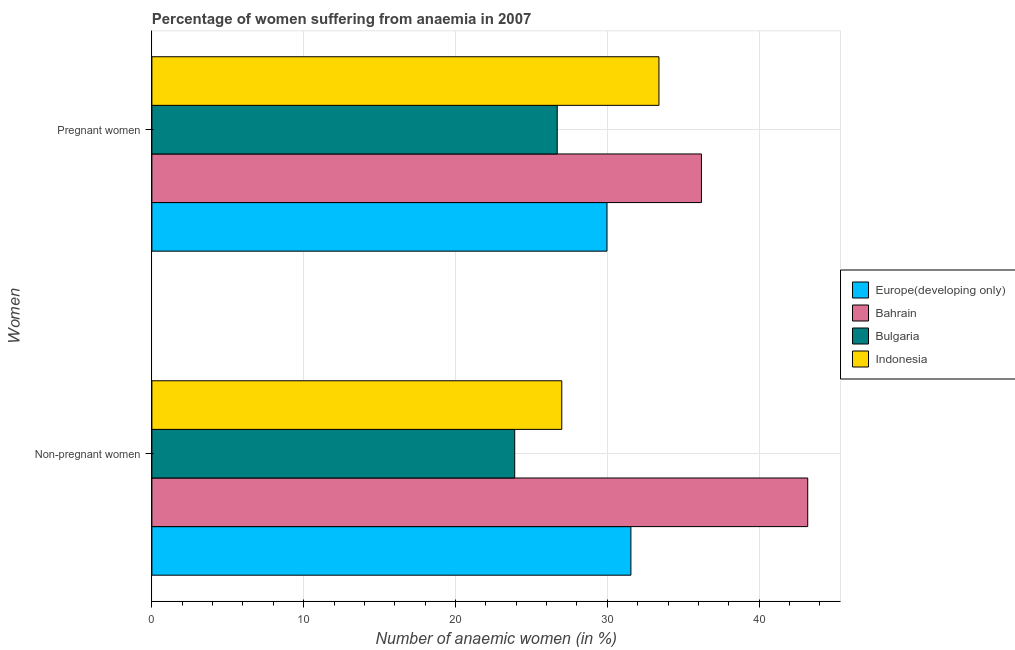How many different coloured bars are there?
Give a very brief answer. 4. Are the number of bars on each tick of the Y-axis equal?
Your response must be concise. Yes. How many bars are there on the 2nd tick from the top?
Give a very brief answer. 4. What is the label of the 2nd group of bars from the top?
Give a very brief answer. Non-pregnant women. What is the percentage of pregnant anaemic women in Europe(developing only)?
Your answer should be compact. 29.98. Across all countries, what is the maximum percentage of non-pregnant anaemic women?
Provide a short and direct response. 43.2. Across all countries, what is the minimum percentage of pregnant anaemic women?
Your answer should be very brief. 26.7. In which country was the percentage of non-pregnant anaemic women maximum?
Keep it short and to the point. Bahrain. In which country was the percentage of pregnant anaemic women minimum?
Provide a short and direct response. Bulgaria. What is the total percentage of pregnant anaemic women in the graph?
Offer a very short reply. 126.28. What is the difference between the percentage of pregnant anaemic women in Bulgaria and that in Indonesia?
Give a very brief answer. -6.7. What is the difference between the percentage of non-pregnant anaemic women in Bahrain and the percentage of pregnant anaemic women in Europe(developing only)?
Keep it short and to the point. 13.22. What is the average percentage of non-pregnant anaemic women per country?
Ensure brevity in your answer.  31.41. What is the difference between the percentage of non-pregnant anaemic women and percentage of pregnant anaemic women in Bulgaria?
Make the answer very short. -2.8. What is the ratio of the percentage of pregnant anaemic women in Indonesia to that in Bahrain?
Give a very brief answer. 0.92. Is the percentage of pregnant anaemic women in Indonesia less than that in Bulgaria?
Keep it short and to the point. No. In how many countries, is the percentage of non-pregnant anaemic women greater than the average percentage of non-pregnant anaemic women taken over all countries?
Provide a succinct answer. 2. What does the 4th bar from the top in Pregnant women represents?
Keep it short and to the point. Europe(developing only). How many countries are there in the graph?
Your response must be concise. 4. What is the difference between two consecutive major ticks on the X-axis?
Give a very brief answer. 10. Does the graph contain grids?
Your response must be concise. Yes. How many legend labels are there?
Your answer should be very brief. 4. How are the legend labels stacked?
Offer a very short reply. Vertical. What is the title of the graph?
Provide a short and direct response. Percentage of women suffering from anaemia in 2007. Does "East Asia (developing only)" appear as one of the legend labels in the graph?
Ensure brevity in your answer.  No. What is the label or title of the X-axis?
Your answer should be very brief. Number of anaemic women (in %). What is the label or title of the Y-axis?
Your answer should be compact. Women. What is the Number of anaemic women (in %) of Europe(developing only) in Non-pregnant women?
Offer a terse response. 31.55. What is the Number of anaemic women (in %) of Bahrain in Non-pregnant women?
Keep it short and to the point. 43.2. What is the Number of anaemic women (in %) of Bulgaria in Non-pregnant women?
Offer a terse response. 23.9. What is the Number of anaemic women (in %) in Europe(developing only) in Pregnant women?
Offer a very short reply. 29.98. What is the Number of anaemic women (in %) in Bahrain in Pregnant women?
Your answer should be compact. 36.2. What is the Number of anaemic women (in %) of Bulgaria in Pregnant women?
Ensure brevity in your answer.  26.7. What is the Number of anaemic women (in %) in Indonesia in Pregnant women?
Provide a succinct answer. 33.4. Across all Women, what is the maximum Number of anaemic women (in %) in Europe(developing only)?
Offer a very short reply. 31.55. Across all Women, what is the maximum Number of anaemic women (in %) in Bahrain?
Your answer should be very brief. 43.2. Across all Women, what is the maximum Number of anaemic women (in %) of Bulgaria?
Your answer should be very brief. 26.7. Across all Women, what is the maximum Number of anaemic women (in %) in Indonesia?
Provide a short and direct response. 33.4. Across all Women, what is the minimum Number of anaemic women (in %) of Europe(developing only)?
Your answer should be very brief. 29.98. Across all Women, what is the minimum Number of anaemic women (in %) in Bahrain?
Keep it short and to the point. 36.2. Across all Women, what is the minimum Number of anaemic women (in %) of Bulgaria?
Your answer should be very brief. 23.9. What is the total Number of anaemic women (in %) in Europe(developing only) in the graph?
Your answer should be compact. 61.53. What is the total Number of anaemic women (in %) in Bahrain in the graph?
Offer a very short reply. 79.4. What is the total Number of anaemic women (in %) in Bulgaria in the graph?
Offer a terse response. 50.6. What is the total Number of anaemic women (in %) of Indonesia in the graph?
Your answer should be very brief. 60.4. What is the difference between the Number of anaemic women (in %) of Europe(developing only) in Non-pregnant women and that in Pregnant women?
Make the answer very short. 1.58. What is the difference between the Number of anaemic women (in %) of Bulgaria in Non-pregnant women and that in Pregnant women?
Your answer should be very brief. -2.8. What is the difference between the Number of anaemic women (in %) in Indonesia in Non-pregnant women and that in Pregnant women?
Offer a terse response. -6.4. What is the difference between the Number of anaemic women (in %) in Europe(developing only) in Non-pregnant women and the Number of anaemic women (in %) in Bahrain in Pregnant women?
Ensure brevity in your answer.  -4.65. What is the difference between the Number of anaemic women (in %) of Europe(developing only) in Non-pregnant women and the Number of anaemic women (in %) of Bulgaria in Pregnant women?
Provide a short and direct response. 4.85. What is the difference between the Number of anaemic women (in %) of Europe(developing only) in Non-pregnant women and the Number of anaemic women (in %) of Indonesia in Pregnant women?
Provide a short and direct response. -1.85. What is the difference between the Number of anaemic women (in %) of Bahrain in Non-pregnant women and the Number of anaemic women (in %) of Bulgaria in Pregnant women?
Provide a succinct answer. 16.5. What is the difference between the Number of anaemic women (in %) of Bulgaria in Non-pregnant women and the Number of anaemic women (in %) of Indonesia in Pregnant women?
Provide a succinct answer. -9.5. What is the average Number of anaemic women (in %) in Europe(developing only) per Women?
Your answer should be very brief. 30.76. What is the average Number of anaemic women (in %) of Bahrain per Women?
Keep it short and to the point. 39.7. What is the average Number of anaemic women (in %) in Bulgaria per Women?
Provide a short and direct response. 25.3. What is the average Number of anaemic women (in %) of Indonesia per Women?
Keep it short and to the point. 30.2. What is the difference between the Number of anaemic women (in %) of Europe(developing only) and Number of anaemic women (in %) of Bahrain in Non-pregnant women?
Your answer should be compact. -11.65. What is the difference between the Number of anaemic women (in %) of Europe(developing only) and Number of anaemic women (in %) of Bulgaria in Non-pregnant women?
Give a very brief answer. 7.65. What is the difference between the Number of anaemic women (in %) of Europe(developing only) and Number of anaemic women (in %) of Indonesia in Non-pregnant women?
Your answer should be compact. 4.55. What is the difference between the Number of anaemic women (in %) in Bahrain and Number of anaemic women (in %) in Bulgaria in Non-pregnant women?
Provide a short and direct response. 19.3. What is the difference between the Number of anaemic women (in %) of Bahrain and Number of anaemic women (in %) of Indonesia in Non-pregnant women?
Ensure brevity in your answer.  16.2. What is the difference between the Number of anaemic women (in %) of Bulgaria and Number of anaemic women (in %) of Indonesia in Non-pregnant women?
Your answer should be very brief. -3.1. What is the difference between the Number of anaemic women (in %) of Europe(developing only) and Number of anaemic women (in %) of Bahrain in Pregnant women?
Ensure brevity in your answer.  -6.22. What is the difference between the Number of anaemic women (in %) in Europe(developing only) and Number of anaemic women (in %) in Bulgaria in Pregnant women?
Your answer should be compact. 3.28. What is the difference between the Number of anaemic women (in %) of Europe(developing only) and Number of anaemic women (in %) of Indonesia in Pregnant women?
Offer a terse response. -3.42. What is the ratio of the Number of anaemic women (in %) of Europe(developing only) in Non-pregnant women to that in Pregnant women?
Your answer should be very brief. 1.05. What is the ratio of the Number of anaemic women (in %) in Bahrain in Non-pregnant women to that in Pregnant women?
Offer a very short reply. 1.19. What is the ratio of the Number of anaemic women (in %) of Bulgaria in Non-pregnant women to that in Pregnant women?
Provide a short and direct response. 0.9. What is the ratio of the Number of anaemic women (in %) of Indonesia in Non-pregnant women to that in Pregnant women?
Offer a terse response. 0.81. What is the difference between the highest and the second highest Number of anaemic women (in %) in Europe(developing only)?
Provide a short and direct response. 1.58. What is the difference between the highest and the lowest Number of anaemic women (in %) in Europe(developing only)?
Provide a short and direct response. 1.58. What is the difference between the highest and the lowest Number of anaemic women (in %) of Bulgaria?
Give a very brief answer. 2.8. 